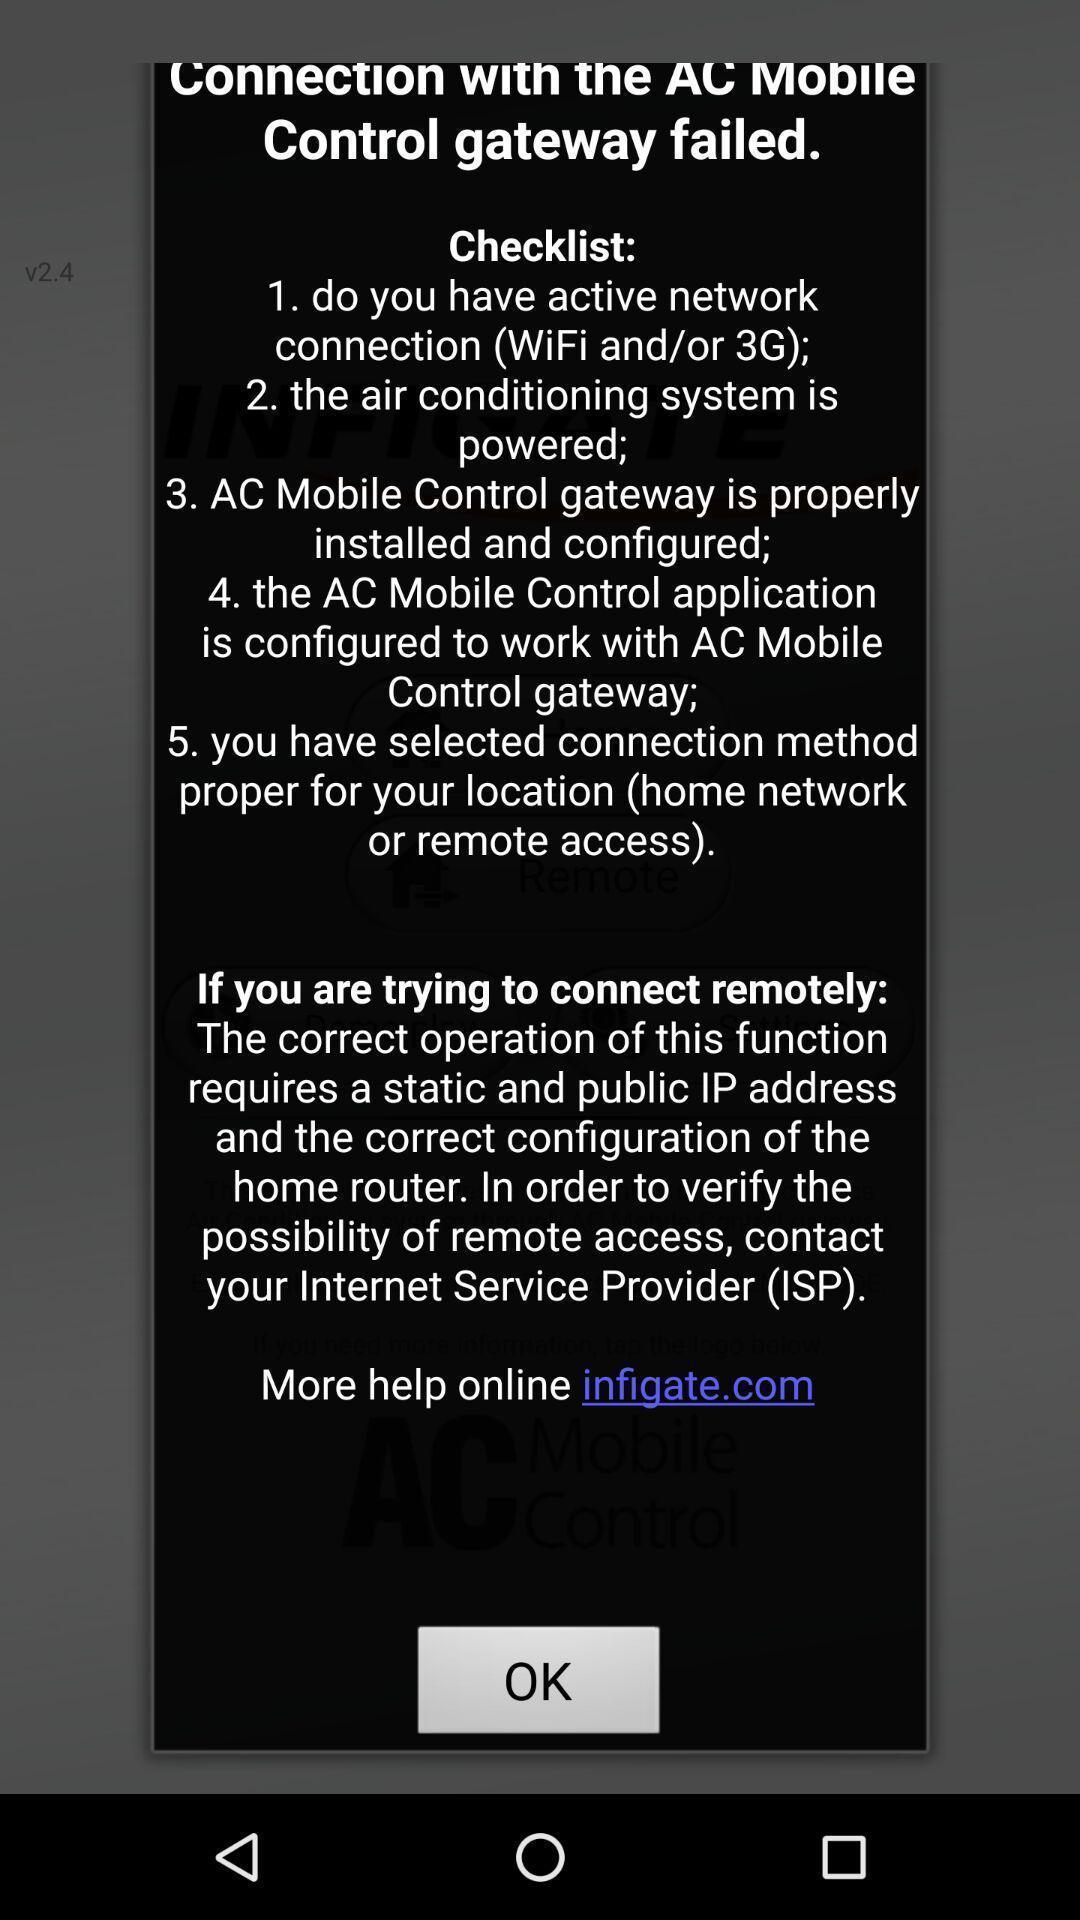Give me a narrative description of this picture. Pop-up showing the checklist. 